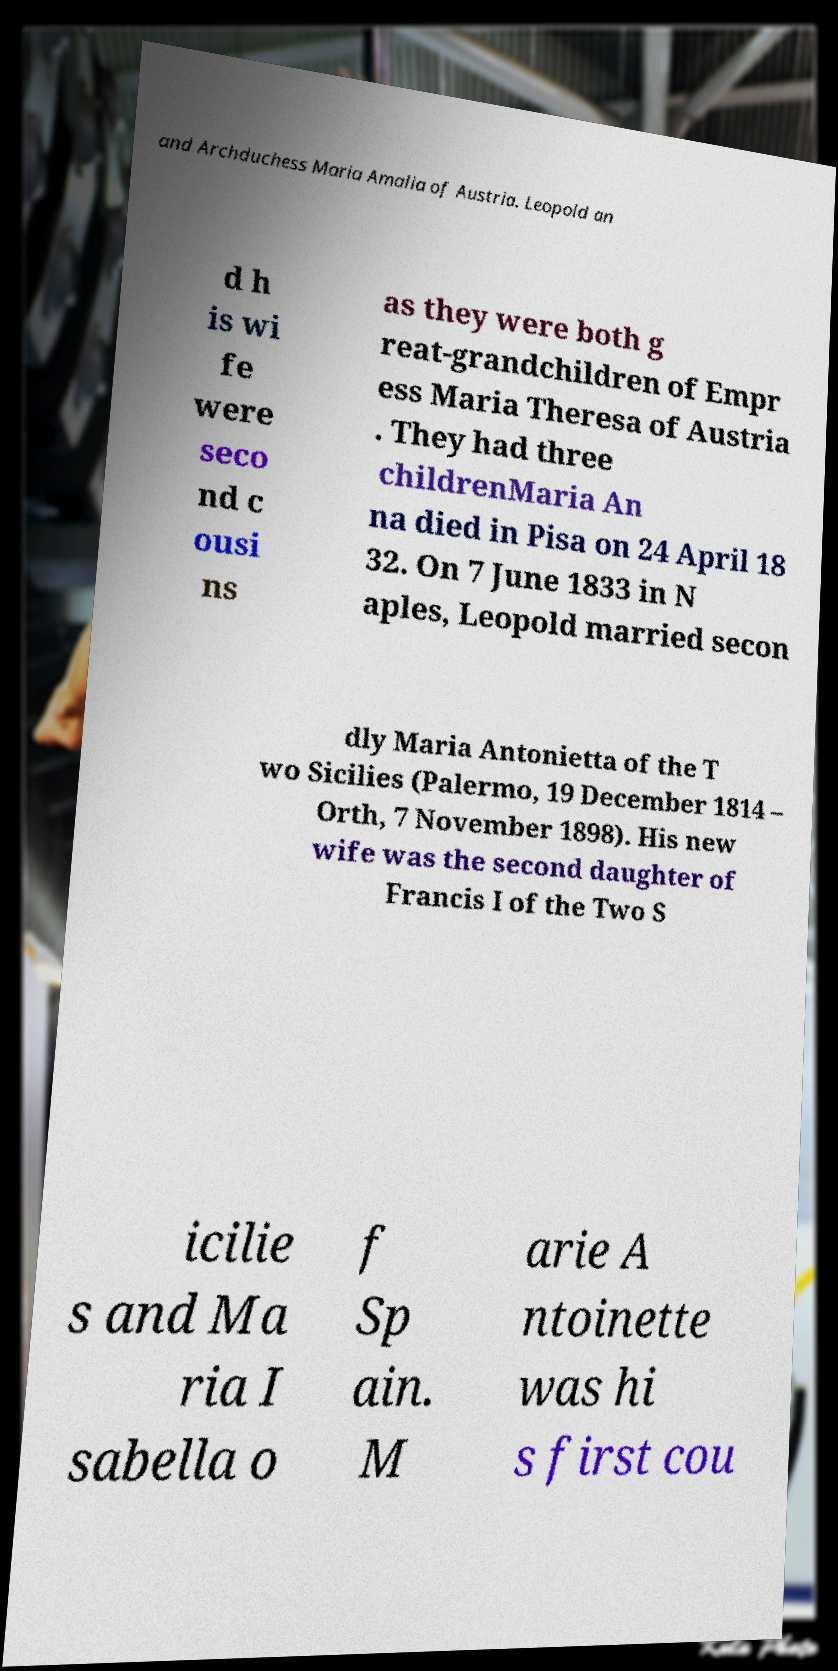What messages or text are displayed in this image? I need them in a readable, typed format. and Archduchess Maria Amalia of Austria. Leopold an d h is wi fe were seco nd c ousi ns as they were both g reat-grandchildren of Empr ess Maria Theresa of Austria . They had three childrenMaria An na died in Pisa on 24 April 18 32. On 7 June 1833 in N aples, Leopold married secon dly Maria Antonietta of the T wo Sicilies (Palermo, 19 December 1814 – Orth, 7 November 1898). His new wife was the second daughter of Francis I of the Two S icilie s and Ma ria I sabella o f Sp ain. M arie A ntoinette was hi s first cou 